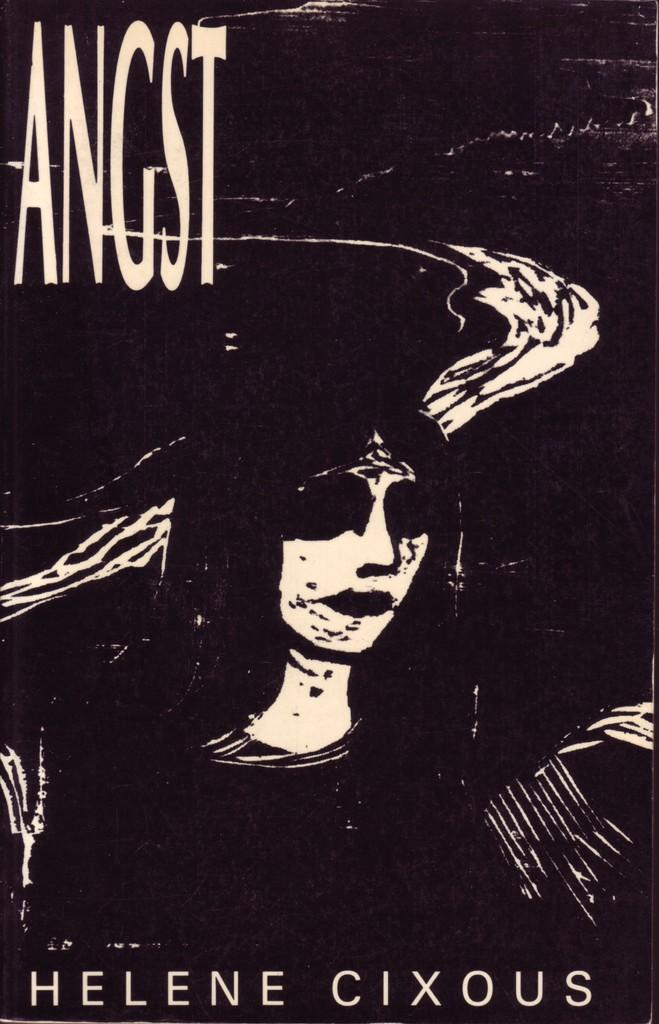What is the main subject in the image? There is a poster in the image. What can be seen in the center of the poster? In the center of the poster, there is one person. Where is text located on the poster? There is text at the top and bottom of the poster. How many balls are bouncing around the person in the image? There are no balls present in the image; it only features a person in the center of the poster. Can you tell me what type of stream is flowing through the poster? There is no stream present in the image; it only features a person in the center of the poster and text at the top and bottom. 